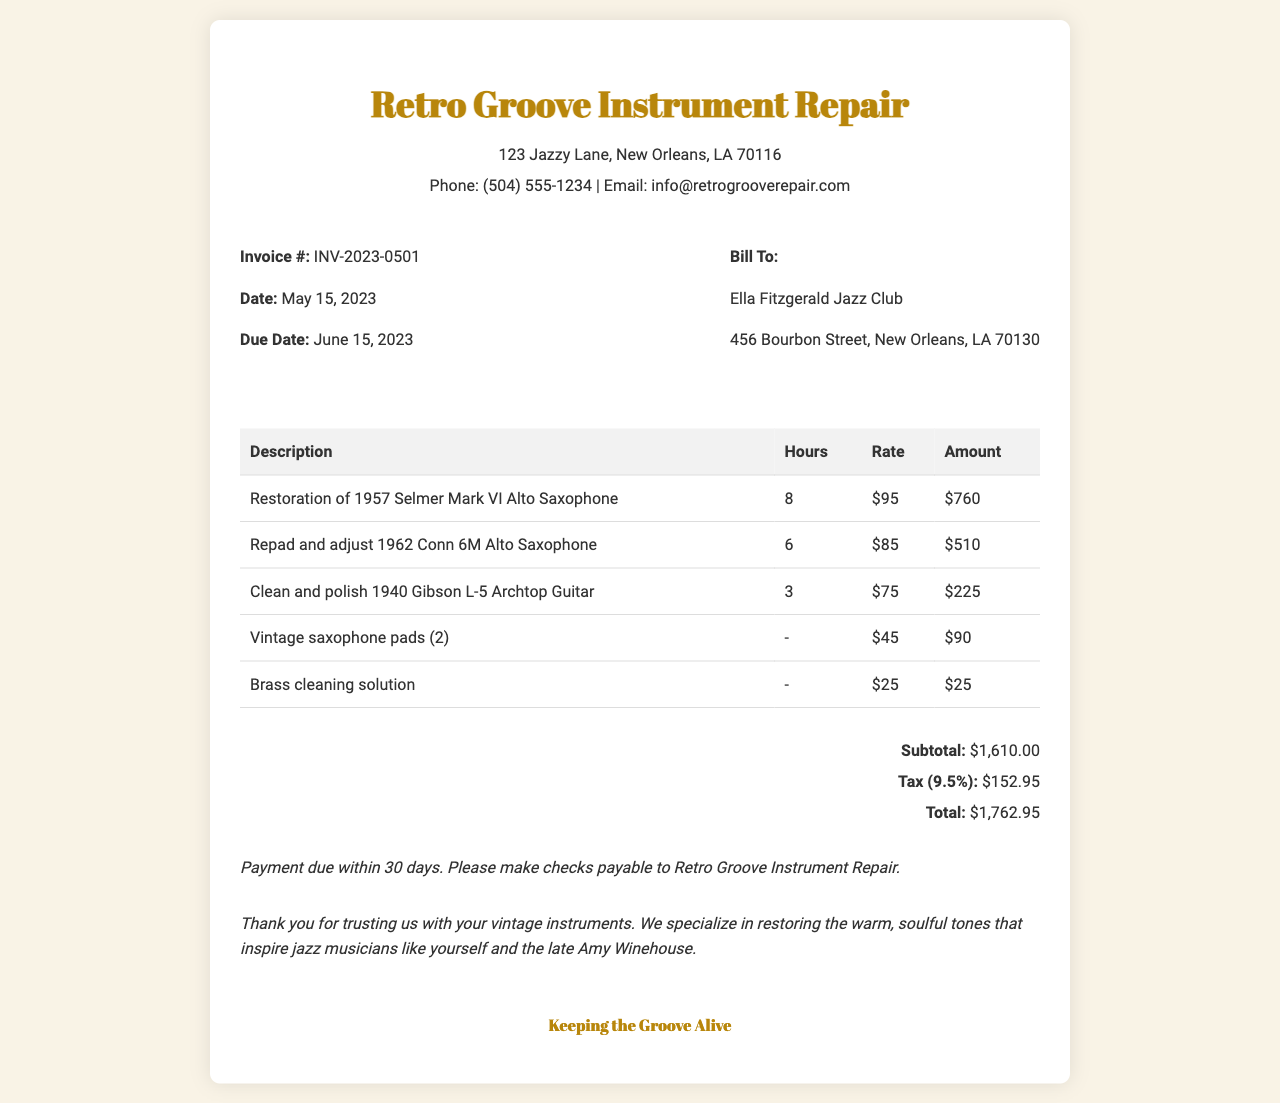What is the invoice number? The invoice number is listed at the top of the document.
Answer: INV-2023-0501 What is the date of the invoice? The date is displayed in the invoice details section.
Answer: May 15, 2023 Who is the bill to? The recipient of the invoice is specified in the document.
Answer: Ella Fitzgerald Jazz Club What is the total amount due? The total amount is calculated at the bottom of the invoice.
Answer: $1,762.95 What is the tax percentage applied? The tax percentage is stated next to the tax amount in the document.
Answer: 9.5% How many hours were spent on the restoration of the 1957 Selmer Mark VI Alto Saxophone? The hours are listed in the table under the restoration item.
Answer: 8 What is the subtotal before tax? The subtotal is provided in the totals section of the invoice.
Answer: $1,610.00 What is the due date for payment? The due date is mentioned in the invoice details section.
Answer: June 15, 2023 What are the payment terms? The payment terms are specified in the payment terms section of the document.
Answer: Payment due within 30 days 